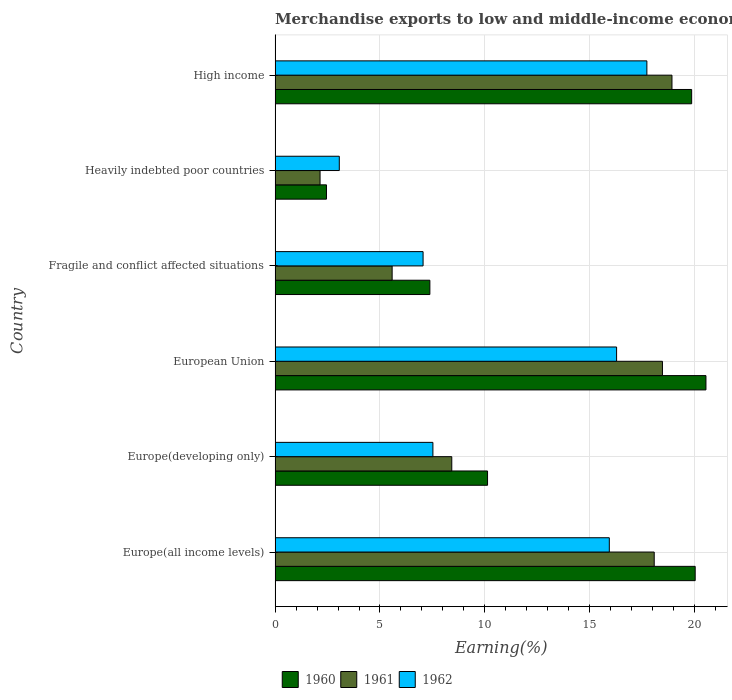How many groups of bars are there?
Provide a short and direct response. 6. How many bars are there on the 2nd tick from the bottom?
Ensure brevity in your answer.  3. What is the label of the 2nd group of bars from the top?
Provide a short and direct response. Heavily indebted poor countries. In how many cases, is the number of bars for a given country not equal to the number of legend labels?
Make the answer very short. 0. What is the percentage of amount earned from merchandise exports in 1961 in Fragile and conflict affected situations?
Make the answer very short. 5.58. Across all countries, what is the maximum percentage of amount earned from merchandise exports in 1961?
Offer a terse response. 18.92. Across all countries, what is the minimum percentage of amount earned from merchandise exports in 1962?
Make the answer very short. 3.06. In which country was the percentage of amount earned from merchandise exports in 1961 maximum?
Keep it short and to the point. High income. In which country was the percentage of amount earned from merchandise exports in 1962 minimum?
Make the answer very short. Heavily indebted poor countries. What is the total percentage of amount earned from merchandise exports in 1961 in the graph?
Give a very brief answer. 71.6. What is the difference between the percentage of amount earned from merchandise exports in 1960 in Europe(developing only) and that in High income?
Provide a succinct answer. -9.73. What is the difference between the percentage of amount earned from merchandise exports in 1960 in European Union and the percentage of amount earned from merchandise exports in 1961 in Fragile and conflict affected situations?
Your answer should be compact. 14.96. What is the average percentage of amount earned from merchandise exports in 1960 per country?
Your answer should be very brief. 13.4. What is the difference between the percentage of amount earned from merchandise exports in 1961 and percentage of amount earned from merchandise exports in 1962 in Europe(all income levels)?
Make the answer very short. 2.14. What is the ratio of the percentage of amount earned from merchandise exports in 1962 in Fragile and conflict affected situations to that in Heavily indebted poor countries?
Give a very brief answer. 2.3. What is the difference between the highest and the second highest percentage of amount earned from merchandise exports in 1960?
Give a very brief answer. 0.51. What is the difference between the highest and the lowest percentage of amount earned from merchandise exports in 1961?
Your answer should be very brief. 16.77. In how many countries, is the percentage of amount earned from merchandise exports in 1960 greater than the average percentage of amount earned from merchandise exports in 1960 taken over all countries?
Offer a very short reply. 3. What does the 2nd bar from the top in Fragile and conflict affected situations represents?
Your answer should be compact. 1961. What does the 3rd bar from the bottom in High income represents?
Ensure brevity in your answer.  1962. Are all the bars in the graph horizontal?
Ensure brevity in your answer.  Yes. How many countries are there in the graph?
Offer a very short reply. 6. What is the difference between two consecutive major ticks on the X-axis?
Keep it short and to the point. 5. Are the values on the major ticks of X-axis written in scientific E-notation?
Your answer should be very brief. No. Does the graph contain any zero values?
Offer a terse response. No. How many legend labels are there?
Offer a very short reply. 3. How are the legend labels stacked?
Give a very brief answer. Horizontal. What is the title of the graph?
Your answer should be compact. Merchandise exports to low and middle-income economies outside region. What is the label or title of the X-axis?
Offer a terse response. Earning(%). What is the Earning(%) of 1960 in Europe(all income levels)?
Provide a succinct answer. 20.02. What is the Earning(%) in 1961 in Europe(all income levels)?
Offer a very short reply. 18.07. What is the Earning(%) of 1962 in Europe(all income levels)?
Your response must be concise. 15.93. What is the Earning(%) of 1960 in Europe(developing only)?
Keep it short and to the point. 10.13. What is the Earning(%) in 1961 in Europe(developing only)?
Make the answer very short. 8.42. What is the Earning(%) of 1962 in Europe(developing only)?
Your answer should be compact. 7.52. What is the Earning(%) of 1960 in European Union?
Your answer should be compact. 20.54. What is the Earning(%) of 1961 in European Union?
Offer a very short reply. 18.46. What is the Earning(%) of 1962 in European Union?
Make the answer very short. 16.28. What is the Earning(%) of 1960 in Fragile and conflict affected situations?
Your answer should be compact. 7.38. What is the Earning(%) of 1961 in Fragile and conflict affected situations?
Give a very brief answer. 5.58. What is the Earning(%) of 1962 in Fragile and conflict affected situations?
Offer a terse response. 7.05. What is the Earning(%) in 1960 in Heavily indebted poor countries?
Give a very brief answer. 2.45. What is the Earning(%) in 1961 in Heavily indebted poor countries?
Your answer should be very brief. 2.14. What is the Earning(%) in 1962 in Heavily indebted poor countries?
Your answer should be compact. 3.06. What is the Earning(%) of 1960 in High income?
Offer a terse response. 19.86. What is the Earning(%) in 1961 in High income?
Make the answer very short. 18.92. What is the Earning(%) of 1962 in High income?
Offer a terse response. 17.72. Across all countries, what is the maximum Earning(%) in 1960?
Ensure brevity in your answer.  20.54. Across all countries, what is the maximum Earning(%) in 1961?
Your answer should be very brief. 18.92. Across all countries, what is the maximum Earning(%) in 1962?
Provide a short and direct response. 17.72. Across all countries, what is the minimum Earning(%) of 1960?
Your answer should be very brief. 2.45. Across all countries, what is the minimum Earning(%) of 1961?
Your answer should be very brief. 2.14. Across all countries, what is the minimum Earning(%) of 1962?
Offer a terse response. 3.06. What is the total Earning(%) in 1960 in the graph?
Offer a terse response. 80.37. What is the total Earning(%) of 1961 in the graph?
Provide a short and direct response. 71.6. What is the total Earning(%) in 1962 in the graph?
Provide a succinct answer. 67.57. What is the difference between the Earning(%) of 1960 in Europe(all income levels) and that in Europe(developing only)?
Your response must be concise. 9.9. What is the difference between the Earning(%) in 1961 in Europe(all income levels) and that in Europe(developing only)?
Ensure brevity in your answer.  9.65. What is the difference between the Earning(%) in 1962 in Europe(all income levels) and that in Europe(developing only)?
Offer a terse response. 8.41. What is the difference between the Earning(%) of 1960 in Europe(all income levels) and that in European Union?
Your answer should be compact. -0.51. What is the difference between the Earning(%) of 1961 in Europe(all income levels) and that in European Union?
Your response must be concise. -0.39. What is the difference between the Earning(%) of 1962 in Europe(all income levels) and that in European Union?
Ensure brevity in your answer.  -0.35. What is the difference between the Earning(%) of 1960 in Europe(all income levels) and that in Fragile and conflict affected situations?
Ensure brevity in your answer.  12.65. What is the difference between the Earning(%) in 1961 in Europe(all income levels) and that in Fragile and conflict affected situations?
Make the answer very short. 12.49. What is the difference between the Earning(%) of 1962 in Europe(all income levels) and that in Fragile and conflict affected situations?
Ensure brevity in your answer.  8.88. What is the difference between the Earning(%) of 1960 in Europe(all income levels) and that in Heavily indebted poor countries?
Make the answer very short. 17.57. What is the difference between the Earning(%) in 1961 in Europe(all income levels) and that in Heavily indebted poor countries?
Keep it short and to the point. 15.93. What is the difference between the Earning(%) in 1962 in Europe(all income levels) and that in Heavily indebted poor countries?
Offer a very short reply. 12.87. What is the difference between the Earning(%) in 1960 in Europe(all income levels) and that in High income?
Your answer should be very brief. 0.17. What is the difference between the Earning(%) of 1961 in Europe(all income levels) and that in High income?
Your response must be concise. -0.85. What is the difference between the Earning(%) in 1962 in Europe(all income levels) and that in High income?
Ensure brevity in your answer.  -1.79. What is the difference between the Earning(%) of 1960 in Europe(developing only) and that in European Union?
Offer a terse response. -10.41. What is the difference between the Earning(%) in 1961 in Europe(developing only) and that in European Union?
Give a very brief answer. -10.04. What is the difference between the Earning(%) in 1962 in Europe(developing only) and that in European Union?
Offer a terse response. -8.76. What is the difference between the Earning(%) in 1960 in Europe(developing only) and that in Fragile and conflict affected situations?
Ensure brevity in your answer.  2.75. What is the difference between the Earning(%) in 1961 in Europe(developing only) and that in Fragile and conflict affected situations?
Provide a succinct answer. 2.84. What is the difference between the Earning(%) of 1962 in Europe(developing only) and that in Fragile and conflict affected situations?
Make the answer very short. 0.47. What is the difference between the Earning(%) in 1960 in Europe(developing only) and that in Heavily indebted poor countries?
Provide a succinct answer. 7.68. What is the difference between the Earning(%) of 1961 in Europe(developing only) and that in Heavily indebted poor countries?
Provide a succinct answer. 6.28. What is the difference between the Earning(%) in 1962 in Europe(developing only) and that in Heavily indebted poor countries?
Your answer should be very brief. 4.46. What is the difference between the Earning(%) of 1960 in Europe(developing only) and that in High income?
Provide a short and direct response. -9.73. What is the difference between the Earning(%) in 1961 in Europe(developing only) and that in High income?
Give a very brief answer. -10.49. What is the difference between the Earning(%) of 1962 in Europe(developing only) and that in High income?
Your response must be concise. -10.2. What is the difference between the Earning(%) in 1960 in European Union and that in Fragile and conflict affected situations?
Keep it short and to the point. 13.16. What is the difference between the Earning(%) in 1961 in European Union and that in Fragile and conflict affected situations?
Offer a terse response. 12.88. What is the difference between the Earning(%) of 1962 in European Union and that in Fragile and conflict affected situations?
Ensure brevity in your answer.  9.22. What is the difference between the Earning(%) in 1960 in European Union and that in Heavily indebted poor countries?
Give a very brief answer. 18.09. What is the difference between the Earning(%) of 1961 in European Union and that in Heavily indebted poor countries?
Make the answer very short. 16.32. What is the difference between the Earning(%) in 1962 in European Union and that in Heavily indebted poor countries?
Your response must be concise. 13.22. What is the difference between the Earning(%) of 1960 in European Union and that in High income?
Your response must be concise. 0.68. What is the difference between the Earning(%) in 1961 in European Union and that in High income?
Your response must be concise. -0.45. What is the difference between the Earning(%) of 1962 in European Union and that in High income?
Provide a succinct answer. -1.44. What is the difference between the Earning(%) in 1960 in Fragile and conflict affected situations and that in Heavily indebted poor countries?
Your response must be concise. 4.93. What is the difference between the Earning(%) of 1961 in Fragile and conflict affected situations and that in Heavily indebted poor countries?
Your answer should be compact. 3.44. What is the difference between the Earning(%) in 1962 in Fragile and conflict affected situations and that in Heavily indebted poor countries?
Your answer should be compact. 3.99. What is the difference between the Earning(%) of 1960 in Fragile and conflict affected situations and that in High income?
Your answer should be very brief. -12.48. What is the difference between the Earning(%) in 1961 in Fragile and conflict affected situations and that in High income?
Provide a succinct answer. -13.34. What is the difference between the Earning(%) of 1962 in Fragile and conflict affected situations and that in High income?
Offer a terse response. -10.67. What is the difference between the Earning(%) of 1960 in Heavily indebted poor countries and that in High income?
Give a very brief answer. -17.41. What is the difference between the Earning(%) of 1961 in Heavily indebted poor countries and that in High income?
Keep it short and to the point. -16.77. What is the difference between the Earning(%) in 1962 in Heavily indebted poor countries and that in High income?
Offer a terse response. -14.66. What is the difference between the Earning(%) in 1960 in Europe(all income levels) and the Earning(%) in 1961 in Europe(developing only)?
Your answer should be compact. 11.6. What is the difference between the Earning(%) in 1960 in Europe(all income levels) and the Earning(%) in 1962 in Europe(developing only)?
Give a very brief answer. 12.5. What is the difference between the Earning(%) of 1961 in Europe(all income levels) and the Earning(%) of 1962 in Europe(developing only)?
Give a very brief answer. 10.55. What is the difference between the Earning(%) of 1960 in Europe(all income levels) and the Earning(%) of 1961 in European Union?
Give a very brief answer. 1.56. What is the difference between the Earning(%) in 1960 in Europe(all income levels) and the Earning(%) in 1962 in European Union?
Make the answer very short. 3.75. What is the difference between the Earning(%) of 1961 in Europe(all income levels) and the Earning(%) of 1962 in European Union?
Ensure brevity in your answer.  1.79. What is the difference between the Earning(%) in 1960 in Europe(all income levels) and the Earning(%) in 1961 in Fragile and conflict affected situations?
Keep it short and to the point. 14.44. What is the difference between the Earning(%) of 1960 in Europe(all income levels) and the Earning(%) of 1962 in Fragile and conflict affected situations?
Your answer should be very brief. 12.97. What is the difference between the Earning(%) in 1961 in Europe(all income levels) and the Earning(%) in 1962 in Fragile and conflict affected situations?
Keep it short and to the point. 11.02. What is the difference between the Earning(%) in 1960 in Europe(all income levels) and the Earning(%) in 1961 in Heavily indebted poor countries?
Ensure brevity in your answer.  17.88. What is the difference between the Earning(%) of 1960 in Europe(all income levels) and the Earning(%) of 1962 in Heavily indebted poor countries?
Your answer should be very brief. 16.96. What is the difference between the Earning(%) of 1961 in Europe(all income levels) and the Earning(%) of 1962 in Heavily indebted poor countries?
Keep it short and to the point. 15.01. What is the difference between the Earning(%) of 1960 in Europe(all income levels) and the Earning(%) of 1961 in High income?
Your answer should be very brief. 1.11. What is the difference between the Earning(%) of 1960 in Europe(all income levels) and the Earning(%) of 1962 in High income?
Ensure brevity in your answer.  2.3. What is the difference between the Earning(%) in 1961 in Europe(all income levels) and the Earning(%) in 1962 in High income?
Your answer should be compact. 0.35. What is the difference between the Earning(%) of 1960 in Europe(developing only) and the Earning(%) of 1961 in European Union?
Offer a very short reply. -8.34. What is the difference between the Earning(%) of 1960 in Europe(developing only) and the Earning(%) of 1962 in European Union?
Your answer should be compact. -6.15. What is the difference between the Earning(%) in 1961 in Europe(developing only) and the Earning(%) in 1962 in European Union?
Provide a succinct answer. -7.86. What is the difference between the Earning(%) in 1960 in Europe(developing only) and the Earning(%) in 1961 in Fragile and conflict affected situations?
Keep it short and to the point. 4.55. What is the difference between the Earning(%) in 1960 in Europe(developing only) and the Earning(%) in 1962 in Fragile and conflict affected situations?
Offer a terse response. 3.07. What is the difference between the Earning(%) in 1961 in Europe(developing only) and the Earning(%) in 1962 in Fragile and conflict affected situations?
Provide a succinct answer. 1.37. What is the difference between the Earning(%) in 1960 in Europe(developing only) and the Earning(%) in 1961 in Heavily indebted poor countries?
Your response must be concise. 7.98. What is the difference between the Earning(%) in 1960 in Europe(developing only) and the Earning(%) in 1962 in Heavily indebted poor countries?
Give a very brief answer. 7.07. What is the difference between the Earning(%) in 1961 in Europe(developing only) and the Earning(%) in 1962 in Heavily indebted poor countries?
Keep it short and to the point. 5.36. What is the difference between the Earning(%) in 1960 in Europe(developing only) and the Earning(%) in 1961 in High income?
Provide a short and direct response. -8.79. What is the difference between the Earning(%) in 1960 in Europe(developing only) and the Earning(%) in 1962 in High income?
Give a very brief answer. -7.59. What is the difference between the Earning(%) of 1961 in Europe(developing only) and the Earning(%) of 1962 in High income?
Keep it short and to the point. -9.3. What is the difference between the Earning(%) of 1960 in European Union and the Earning(%) of 1961 in Fragile and conflict affected situations?
Offer a terse response. 14.96. What is the difference between the Earning(%) in 1960 in European Union and the Earning(%) in 1962 in Fragile and conflict affected situations?
Make the answer very short. 13.48. What is the difference between the Earning(%) of 1961 in European Union and the Earning(%) of 1962 in Fragile and conflict affected situations?
Make the answer very short. 11.41. What is the difference between the Earning(%) in 1960 in European Union and the Earning(%) in 1961 in Heavily indebted poor countries?
Your answer should be very brief. 18.39. What is the difference between the Earning(%) in 1960 in European Union and the Earning(%) in 1962 in Heavily indebted poor countries?
Your response must be concise. 17.48. What is the difference between the Earning(%) of 1961 in European Union and the Earning(%) of 1962 in Heavily indebted poor countries?
Offer a terse response. 15.4. What is the difference between the Earning(%) in 1960 in European Union and the Earning(%) in 1961 in High income?
Offer a terse response. 1.62. What is the difference between the Earning(%) of 1960 in European Union and the Earning(%) of 1962 in High income?
Offer a terse response. 2.82. What is the difference between the Earning(%) of 1961 in European Union and the Earning(%) of 1962 in High income?
Keep it short and to the point. 0.74. What is the difference between the Earning(%) of 1960 in Fragile and conflict affected situations and the Earning(%) of 1961 in Heavily indebted poor countries?
Provide a succinct answer. 5.23. What is the difference between the Earning(%) in 1960 in Fragile and conflict affected situations and the Earning(%) in 1962 in Heavily indebted poor countries?
Offer a terse response. 4.32. What is the difference between the Earning(%) in 1961 in Fragile and conflict affected situations and the Earning(%) in 1962 in Heavily indebted poor countries?
Your response must be concise. 2.52. What is the difference between the Earning(%) in 1960 in Fragile and conflict affected situations and the Earning(%) in 1961 in High income?
Your answer should be compact. -11.54. What is the difference between the Earning(%) of 1960 in Fragile and conflict affected situations and the Earning(%) of 1962 in High income?
Ensure brevity in your answer.  -10.34. What is the difference between the Earning(%) in 1961 in Fragile and conflict affected situations and the Earning(%) in 1962 in High income?
Give a very brief answer. -12.14. What is the difference between the Earning(%) in 1960 in Heavily indebted poor countries and the Earning(%) in 1961 in High income?
Offer a very short reply. -16.47. What is the difference between the Earning(%) in 1960 in Heavily indebted poor countries and the Earning(%) in 1962 in High income?
Your answer should be compact. -15.27. What is the difference between the Earning(%) in 1961 in Heavily indebted poor countries and the Earning(%) in 1962 in High income?
Offer a terse response. -15.58. What is the average Earning(%) in 1960 per country?
Ensure brevity in your answer.  13.4. What is the average Earning(%) in 1961 per country?
Keep it short and to the point. 11.93. What is the average Earning(%) of 1962 per country?
Offer a very short reply. 11.26. What is the difference between the Earning(%) of 1960 and Earning(%) of 1961 in Europe(all income levels)?
Your answer should be compact. 1.95. What is the difference between the Earning(%) of 1960 and Earning(%) of 1962 in Europe(all income levels)?
Provide a succinct answer. 4.09. What is the difference between the Earning(%) of 1961 and Earning(%) of 1962 in Europe(all income levels)?
Provide a short and direct response. 2.14. What is the difference between the Earning(%) of 1960 and Earning(%) of 1961 in Europe(developing only)?
Keep it short and to the point. 1.7. What is the difference between the Earning(%) of 1960 and Earning(%) of 1962 in Europe(developing only)?
Provide a succinct answer. 2.6. What is the difference between the Earning(%) in 1961 and Earning(%) in 1962 in Europe(developing only)?
Ensure brevity in your answer.  0.9. What is the difference between the Earning(%) of 1960 and Earning(%) of 1961 in European Union?
Offer a very short reply. 2.07. What is the difference between the Earning(%) in 1960 and Earning(%) in 1962 in European Union?
Your answer should be very brief. 4.26. What is the difference between the Earning(%) in 1961 and Earning(%) in 1962 in European Union?
Your answer should be compact. 2.19. What is the difference between the Earning(%) of 1960 and Earning(%) of 1961 in Fragile and conflict affected situations?
Make the answer very short. 1.8. What is the difference between the Earning(%) in 1960 and Earning(%) in 1962 in Fragile and conflict affected situations?
Offer a terse response. 0.32. What is the difference between the Earning(%) in 1961 and Earning(%) in 1962 in Fragile and conflict affected situations?
Give a very brief answer. -1.47. What is the difference between the Earning(%) of 1960 and Earning(%) of 1961 in Heavily indebted poor countries?
Ensure brevity in your answer.  0.31. What is the difference between the Earning(%) of 1960 and Earning(%) of 1962 in Heavily indebted poor countries?
Your answer should be very brief. -0.61. What is the difference between the Earning(%) of 1961 and Earning(%) of 1962 in Heavily indebted poor countries?
Provide a succinct answer. -0.92. What is the difference between the Earning(%) in 1960 and Earning(%) in 1961 in High income?
Offer a terse response. 0.94. What is the difference between the Earning(%) in 1960 and Earning(%) in 1962 in High income?
Make the answer very short. 2.13. What is the difference between the Earning(%) in 1961 and Earning(%) in 1962 in High income?
Provide a short and direct response. 1.2. What is the ratio of the Earning(%) of 1960 in Europe(all income levels) to that in Europe(developing only)?
Your response must be concise. 1.98. What is the ratio of the Earning(%) in 1961 in Europe(all income levels) to that in Europe(developing only)?
Ensure brevity in your answer.  2.15. What is the ratio of the Earning(%) in 1962 in Europe(all income levels) to that in Europe(developing only)?
Ensure brevity in your answer.  2.12. What is the ratio of the Earning(%) in 1960 in Europe(all income levels) to that in European Union?
Your answer should be compact. 0.97. What is the ratio of the Earning(%) of 1961 in Europe(all income levels) to that in European Union?
Give a very brief answer. 0.98. What is the ratio of the Earning(%) in 1962 in Europe(all income levels) to that in European Union?
Your answer should be compact. 0.98. What is the ratio of the Earning(%) of 1960 in Europe(all income levels) to that in Fragile and conflict affected situations?
Provide a short and direct response. 2.71. What is the ratio of the Earning(%) in 1961 in Europe(all income levels) to that in Fragile and conflict affected situations?
Provide a succinct answer. 3.24. What is the ratio of the Earning(%) in 1962 in Europe(all income levels) to that in Fragile and conflict affected situations?
Your answer should be compact. 2.26. What is the ratio of the Earning(%) of 1960 in Europe(all income levels) to that in Heavily indebted poor countries?
Your answer should be very brief. 8.17. What is the ratio of the Earning(%) of 1961 in Europe(all income levels) to that in Heavily indebted poor countries?
Your response must be concise. 8.43. What is the ratio of the Earning(%) in 1962 in Europe(all income levels) to that in Heavily indebted poor countries?
Ensure brevity in your answer.  5.2. What is the ratio of the Earning(%) of 1960 in Europe(all income levels) to that in High income?
Your answer should be compact. 1.01. What is the ratio of the Earning(%) of 1961 in Europe(all income levels) to that in High income?
Provide a succinct answer. 0.96. What is the ratio of the Earning(%) of 1962 in Europe(all income levels) to that in High income?
Make the answer very short. 0.9. What is the ratio of the Earning(%) of 1960 in Europe(developing only) to that in European Union?
Your response must be concise. 0.49. What is the ratio of the Earning(%) in 1961 in Europe(developing only) to that in European Union?
Your answer should be very brief. 0.46. What is the ratio of the Earning(%) of 1962 in Europe(developing only) to that in European Union?
Your answer should be very brief. 0.46. What is the ratio of the Earning(%) in 1960 in Europe(developing only) to that in Fragile and conflict affected situations?
Offer a very short reply. 1.37. What is the ratio of the Earning(%) in 1961 in Europe(developing only) to that in Fragile and conflict affected situations?
Your answer should be compact. 1.51. What is the ratio of the Earning(%) in 1962 in Europe(developing only) to that in Fragile and conflict affected situations?
Ensure brevity in your answer.  1.07. What is the ratio of the Earning(%) of 1960 in Europe(developing only) to that in Heavily indebted poor countries?
Your answer should be very brief. 4.13. What is the ratio of the Earning(%) in 1961 in Europe(developing only) to that in Heavily indebted poor countries?
Offer a very short reply. 3.93. What is the ratio of the Earning(%) in 1962 in Europe(developing only) to that in Heavily indebted poor countries?
Provide a short and direct response. 2.46. What is the ratio of the Earning(%) in 1960 in Europe(developing only) to that in High income?
Your answer should be very brief. 0.51. What is the ratio of the Earning(%) of 1961 in Europe(developing only) to that in High income?
Give a very brief answer. 0.45. What is the ratio of the Earning(%) of 1962 in Europe(developing only) to that in High income?
Keep it short and to the point. 0.42. What is the ratio of the Earning(%) of 1960 in European Union to that in Fragile and conflict affected situations?
Your answer should be very brief. 2.78. What is the ratio of the Earning(%) of 1961 in European Union to that in Fragile and conflict affected situations?
Make the answer very short. 3.31. What is the ratio of the Earning(%) in 1962 in European Union to that in Fragile and conflict affected situations?
Make the answer very short. 2.31. What is the ratio of the Earning(%) of 1960 in European Union to that in Heavily indebted poor countries?
Provide a succinct answer. 8.38. What is the ratio of the Earning(%) in 1961 in European Union to that in Heavily indebted poor countries?
Your response must be concise. 8.61. What is the ratio of the Earning(%) of 1962 in European Union to that in Heavily indebted poor countries?
Provide a short and direct response. 5.32. What is the ratio of the Earning(%) of 1960 in European Union to that in High income?
Provide a succinct answer. 1.03. What is the ratio of the Earning(%) of 1962 in European Union to that in High income?
Your answer should be compact. 0.92. What is the ratio of the Earning(%) of 1960 in Fragile and conflict affected situations to that in Heavily indebted poor countries?
Give a very brief answer. 3.01. What is the ratio of the Earning(%) in 1961 in Fragile and conflict affected situations to that in Heavily indebted poor countries?
Offer a terse response. 2.6. What is the ratio of the Earning(%) of 1962 in Fragile and conflict affected situations to that in Heavily indebted poor countries?
Provide a short and direct response. 2.3. What is the ratio of the Earning(%) in 1960 in Fragile and conflict affected situations to that in High income?
Provide a succinct answer. 0.37. What is the ratio of the Earning(%) of 1961 in Fragile and conflict affected situations to that in High income?
Offer a very short reply. 0.29. What is the ratio of the Earning(%) of 1962 in Fragile and conflict affected situations to that in High income?
Your response must be concise. 0.4. What is the ratio of the Earning(%) of 1960 in Heavily indebted poor countries to that in High income?
Give a very brief answer. 0.12. What is the ratio of the Earning(%) of 1961 in Heavily indebted poor countries to that in High income?
Provide a succinct answer. 0.11. What is the ratio of the Earning(%) in 1962 in Heavily indebted poor countries to that in High income?
Keep it short and to the point. 0.17. What is the difference between the highest and the second highest Earning(%) of 1960?
Provide a succinct answer. 0.51. What is the difference between the highest and the second highest Earning(%) of 1961?
Provide a succinct answer. 0.45. What is the difference between the highest and the second highest Earning(%) in 1962?
Give a very brief answer. 1.44. What is the difference between the highest and the lowest Earning(%) of 1960?
Your answer should be very brief. 18.09. What is the difference between the highest and the lowest Earning(%) in 1961?
Keep it short and to the point. 16.77. What is the difference between the highest and the lowest Earning(%) in 1962?
Your response must be concise. 14.66. 